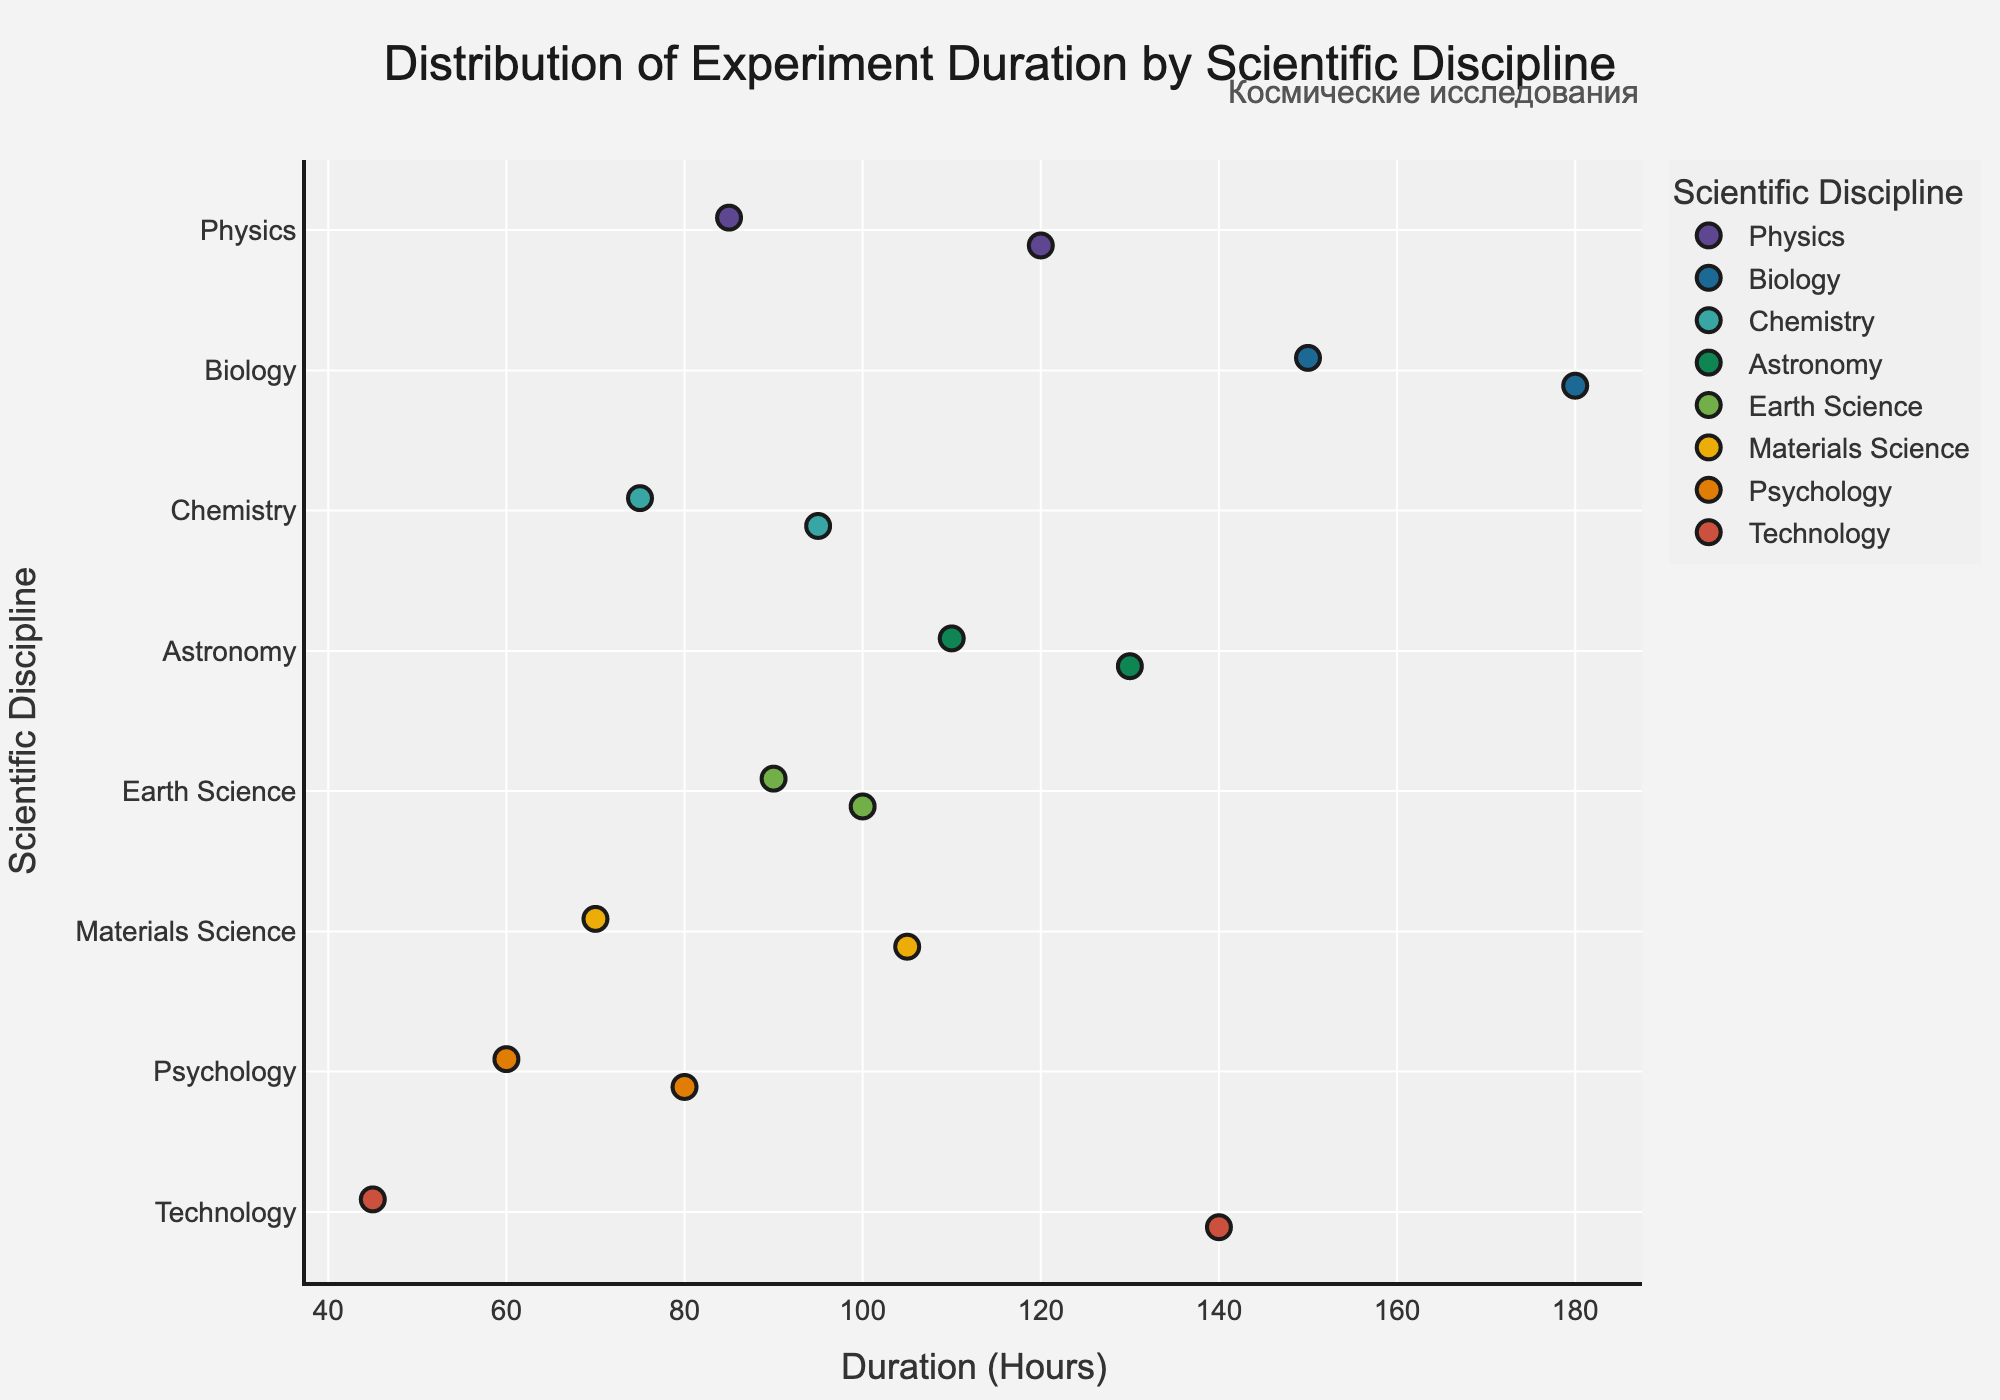Which scientific discipline has the longest duration experiment? By looking at the data points on the graph, Biology has the experiment with the greatest duration, which is the "Plant Growth in Space" experiment lasting 180 hours.
Answer: Biology How many experiments took more than 100 hours? Count the number of data points with values greater than 100 on the x-axis. We can see 7 experiments: Microgravity Fluid Dynamics, Plant Growth in Space, Human Cardiovascular Study, Solar Wind Analysis, Exoplanet Transit Observation, Advanced Life Support Systems, Metal Alloy Formation.
Answer: 7 What is the range of experiment durations in the Chemistry discipline? Identify the minimum and maximum hour values for Chemistry, which are Polymer Synthesis in Microgravity (75) and Crystal Growth Experiment (95). The range is the difference between these values: 95 - 75 = 20.
Answer: 20 Which scientific discipline has the most variation in experiment duration? Look for disciplines with the most spread out data points. Physics has experiments ranging from 85 to 120 hours, providing a significant variation of 35 hours.
Answer: Physics What is the average duration of all experiments in Earth Science? Add the durations of Atmospheric Composition Monitoring and Ocean Current Tracking (100 + 90) and divide by the number of experiments (2). The average is (100 + 90) / 2 = 95 hours.
Answer: 95 hours Which experiment in the Psychology discipline has the shortest duration? Look within the Psychology category and identify the experiments: Crew Interaction Study (60 hours) and Sleep Pattern Analysis (80 hours). The shorter of the two is the Crew Interaction Study.
Answer: Crew Interaction Study How do the durations of the Technology experiments compare? Compare the Robotic Arm Precision Test (45 hours) with the Advanced Life Support Systems (140 hours) to see which is longer. Advanced Life Support Systems is significantly longer than Robotic Arm Precision Test.
Answer: Advanced Life Support Systems Are there more experiments in Physics or Biology? Count the data points in each category. Physics has 2 experiments (Microgravity Fluid Dynamics, Cosmic Ray Detection), and Biology has 2 (Plant Growth in Space, Human Cardiovascular Study), making it equal in numbers.
Answer: Equal What is the median duration of experiments in the given data set? List out all the durations, sort them, and find the middle value(s): 45, 60, 70, 75, 80, 85, 90, 95, 100, 105, 110, 120, 130, 140, 150, 180. With 16 values, the median is the average of the 8th and 9th values: (95 + 100) / 2 = 97.5 hours.
Answer: 97.5 hours 